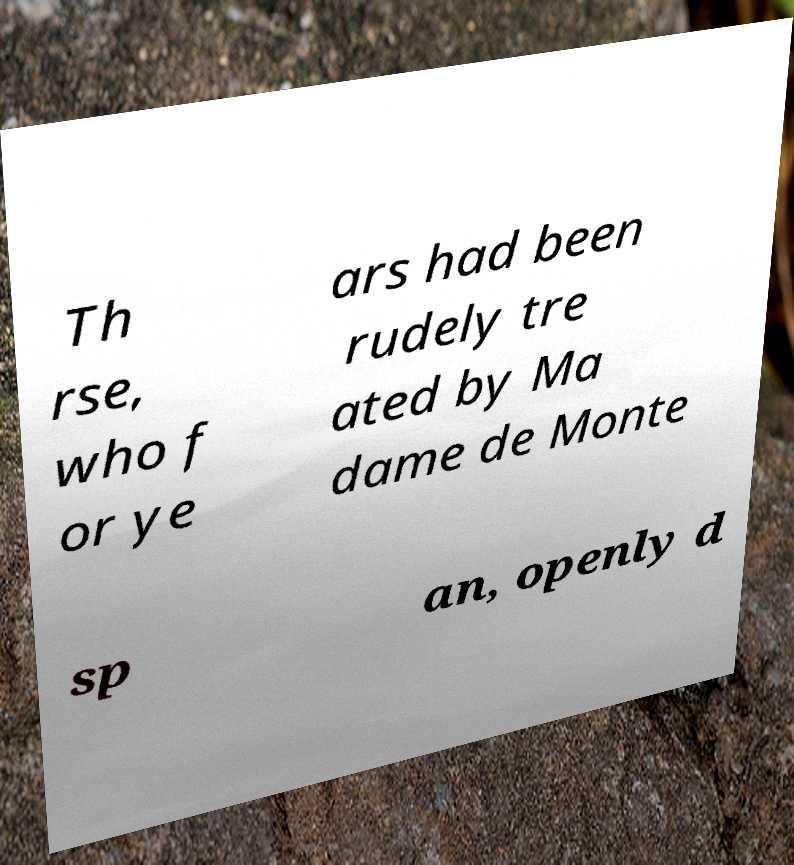Can you accurately transcribe the text from the provided image for me? Th rse, who f or ye ars had been rudely tre ated by Ma dame de Monte sp an, openly d 